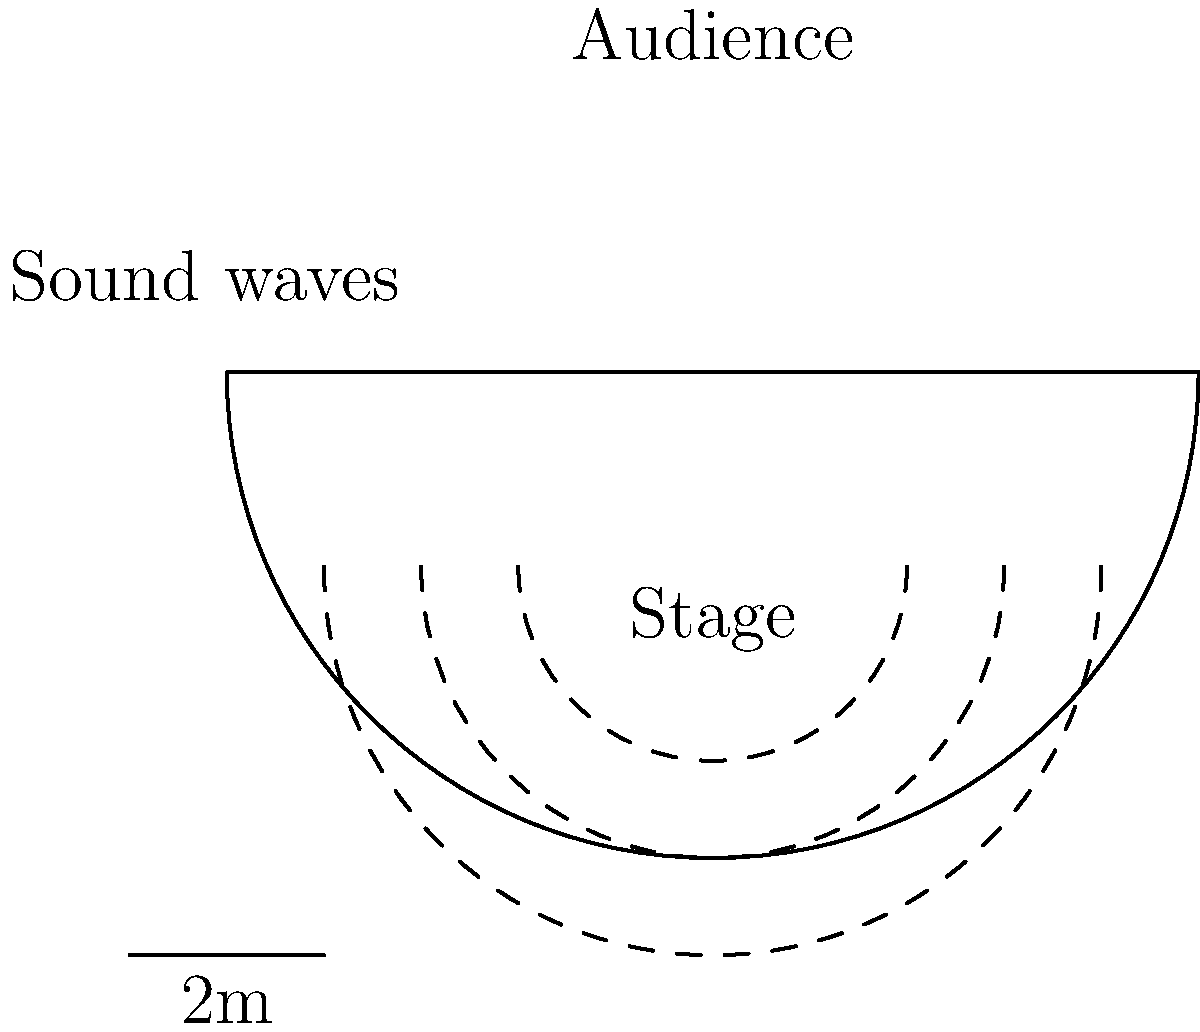In the outdoor amphitheater shown above, a street performer is giving a presentation on the stage. The amphitheater's curved wall helps to reflect sound towards the audience. If the speed of sound in air is 343 m/s and the distance from the performer to the farthest audience member is 10 meters, what is the minimum time it takes for the sound to reach this audience member? To solve this problem, we need to follow these steps:

1. Identify the relevant information:
   - Speed of sound in air: $v = 343$ m/s
   - Distance from performer to farthest audience member: $d = 10$ m

2. Recall the equation relating distance, speed, and time:
   $$ d = vt $$
   where $d$ is distance, $v$ is velocity, and $t$ is time.

3. Rearrange the equation to solve for time:
   $$ t = \frac{d}{v} $$

4. Substitute the known values:
   $$ t = \frac{10 \text{ m}}{343 \text{ m/s}} $$

5. Calculate the result:
   $$ t \approx 0.0292 \text{ s} $$

6. Convert to milliseconds for a more practical unit:
   $$ t \approx 29.2 \text{ ms} $$

This calculation gives us the minimum time for the sound to travel directly from the performer to the farthest audience member. In reality, some sound waves may take slightly longer paths due to reflections off the amphitheater's curved wall, but these differences would be negligible for human perception.
Answer: 29.2 ms 